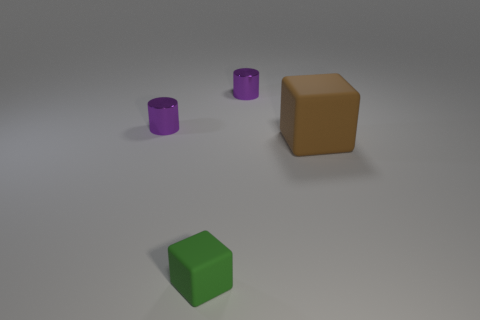Are there any big blocks?
Offer a very short reply. Yes. There is a matte cube that is in front of the large object; how many purple cylinders are on the right side of it?
Your answer should be compact. 1. The small purple shiny thing that is right of the small rubber object has what shape?
Keep it short and to the point. Cylinder. What is the material of the tiny purple object that is behind the small cylinder in front of the shiny cylinder that is right of the tiny matte block?
Your answer should be very brief. Metal. What number of other objects are the same size as the brown matte cube?
Give a very brief answer. 0. The big thing has what color?
Give a very brief answer. Brown. What color is the matte cube behind the rubber object in front of the brown rubber cube?
Provide a succinct answer. Brown. There is a cube that is on the right side of the small shiny cylinder to the right of the green object; how many metallic cylinders are right of it?
Your answer should be compact. 0. There is a big matte cube; are there any small purple metallic cylinders behind it?
Provide a short and direct response. Yes. What number of spheres are tiny things or tiny shiny objects?
Ensure brevity in your answer.  0. 